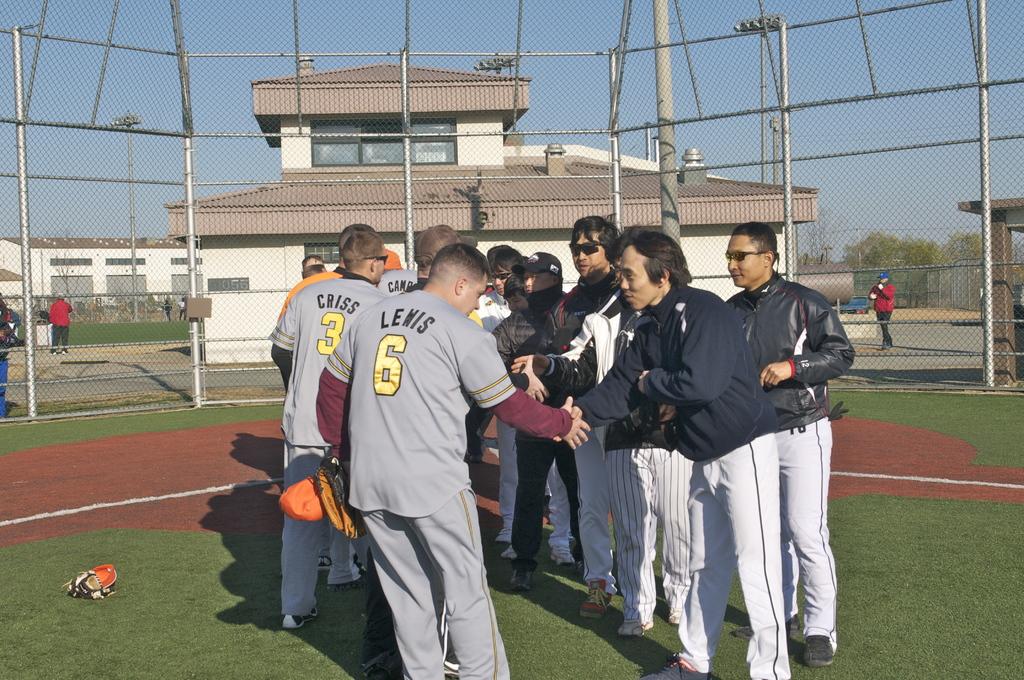What is the name of the player in the number 6 shirt?
Offer a very short reply. Lewis. 